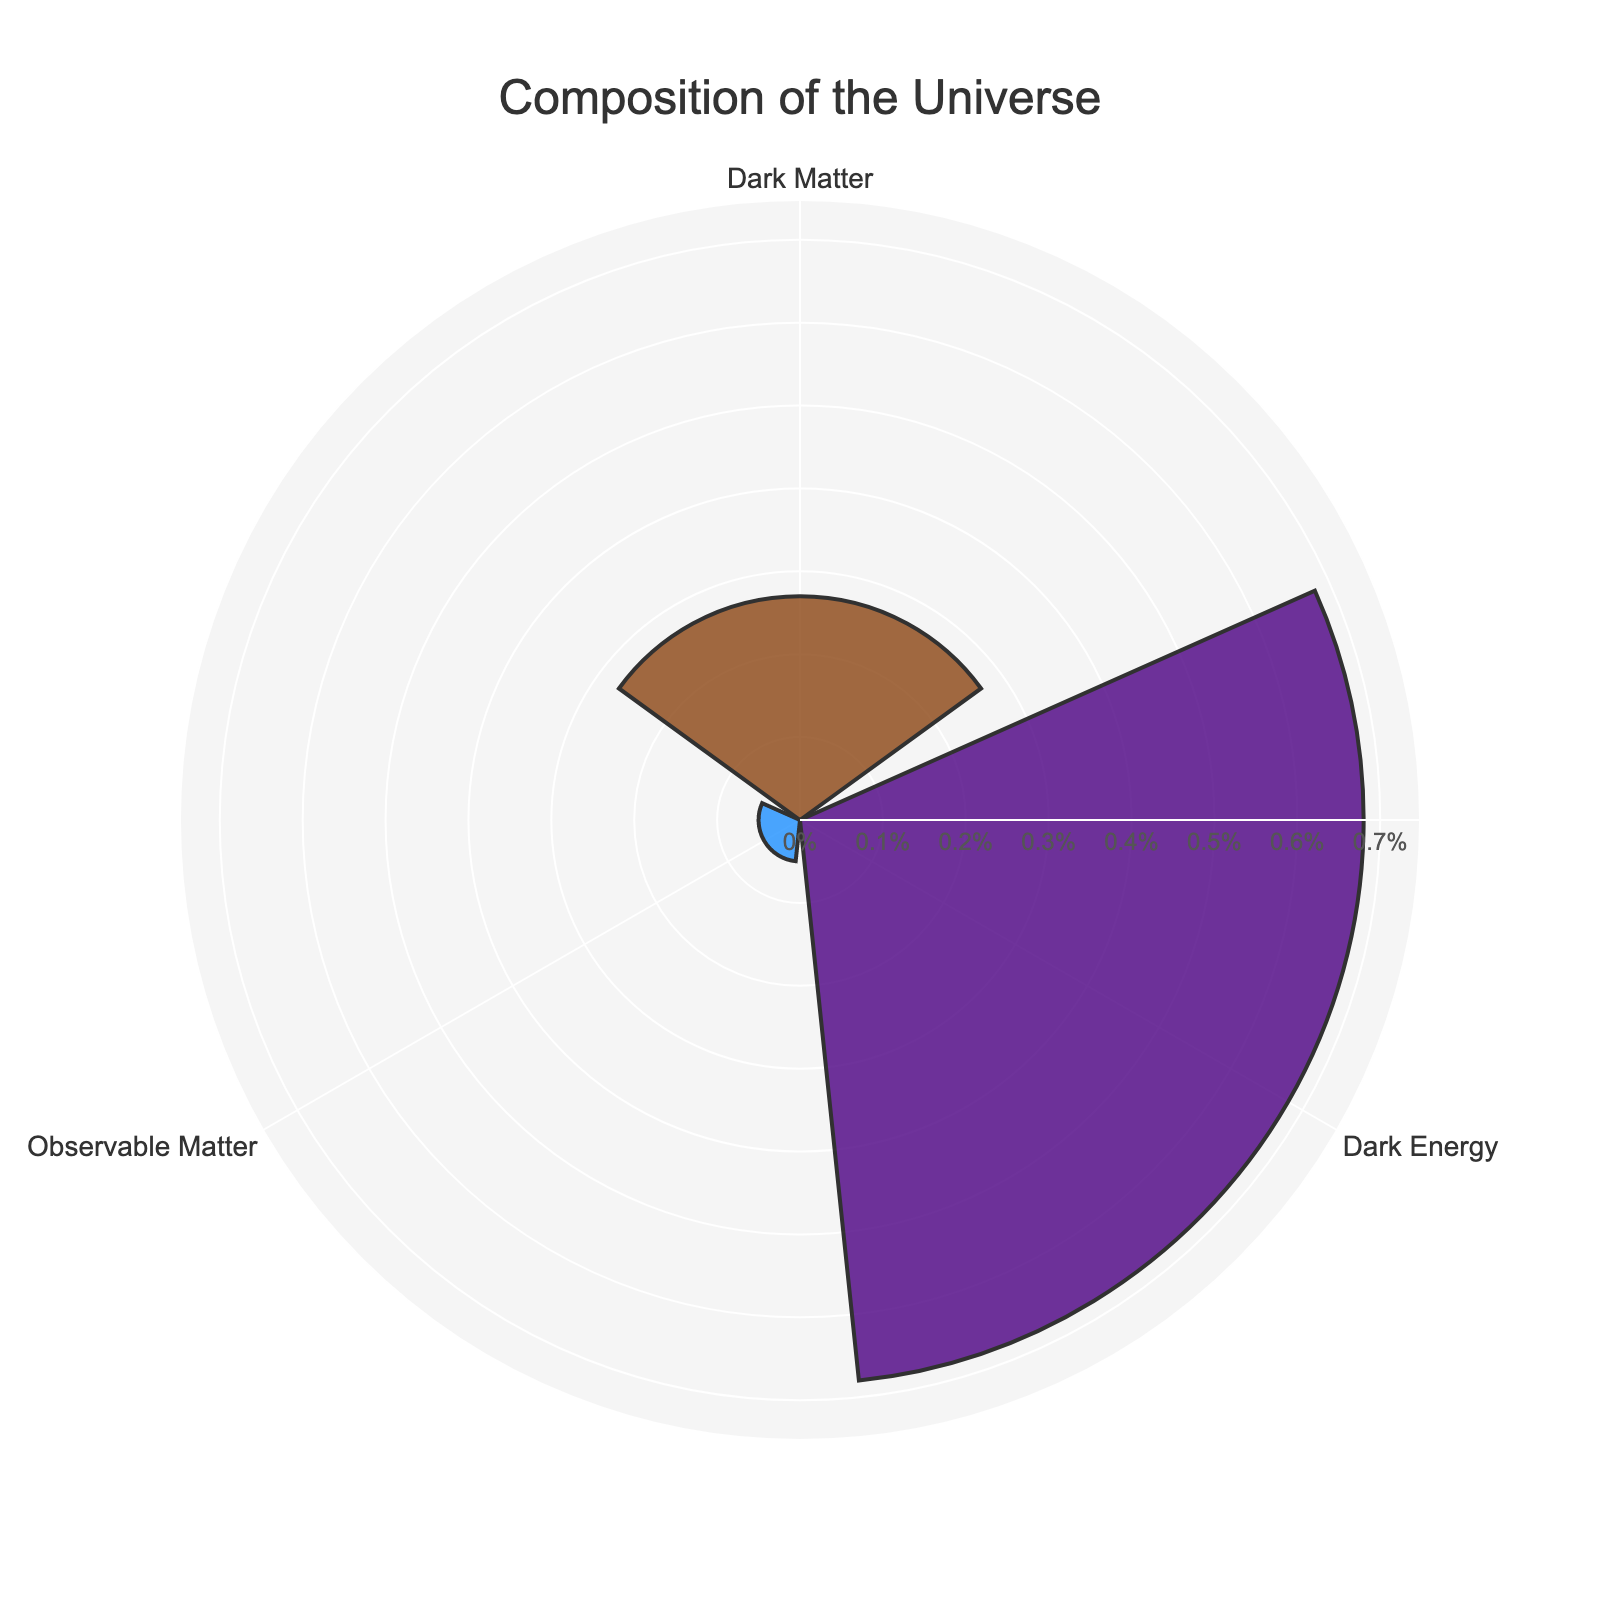What's the title of the chart? The title of the chart is a prominent text usually located at the top center. In this case, it reads "Composition of the Universe."
Answer: Composition of the Universe How many groups are in the rose chart? The chart consists of distinct segments, each representing a different group. By visually counting these segments, we see there are three groups.
Answer: Three Which group has the largest proportion in the universe? By comparing the lengths of the segments in the chart, the longest segment represents the largest proportion. Here, it is clear that "Dark Energy" has the largest share.
Answer: Dark Energy What's the combined proportion of Dark Matter and Observable Matter in the universe? To find the combined proportion, sum the proportions of the individual groups: 0.27 (Dark Matter) + 0.05 (Observable Matter) = 0.32.
Answer: 0.32 How much greater is the proportion of Dark Energy than Dark Matter? Subtract the proportion of Dark Matter from the proportion of Dark Energy: 0.68 (Dark Energy) - 0.27 (Dark Matter) = 0.41.
Answer: 0.41 List the groups in descending order of their proportions. By arranging the groups based on the length of their segments from largest to smallest, we get: Dark Energy, Dark Matter, Observable Matter.
Answer: Dark Energy, Dark Matter, Observable Matter What visual element is used to indicate each segment's proportion? The length of each segment radiating from the center indicates the proportion it represents, and distinct colors help in differentiating the groups.
Answer: Length and color Which group has the smallest proportion, and what is its percentage? The shortest segment corresponds to the smallest proportion, which belongs to "Observable Matter." The percentage of this group is 0.05 * 100 = 5%.
Answer: Observable Matter, 5% How does the length of the "Dark Matter" segment compare to the "Observable Matter" segment? By comparing their lengths visually, the segment for Dark Matter is significantly longer than the segment for Observable Matter, indicating a greater proportion.
Answer: Longer 